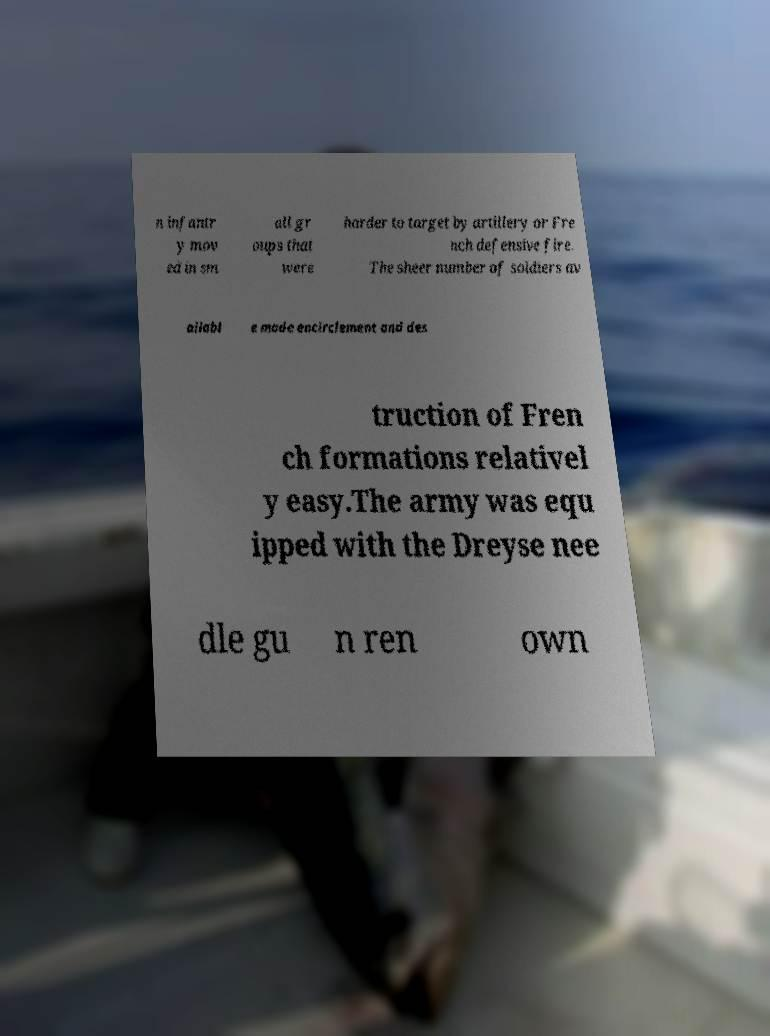Can you accurately transcribe the text from the provided image for me? n infantr y mov ed in sm all gr oups that were harder to target by artillery or Fre nch defensive fire. The sheer number of soldiers av ailabl e made encirclement and des truction of Fren ch formations relativel y easy.The army was equ ipped with the Dreyse nee dle gu n ren own 